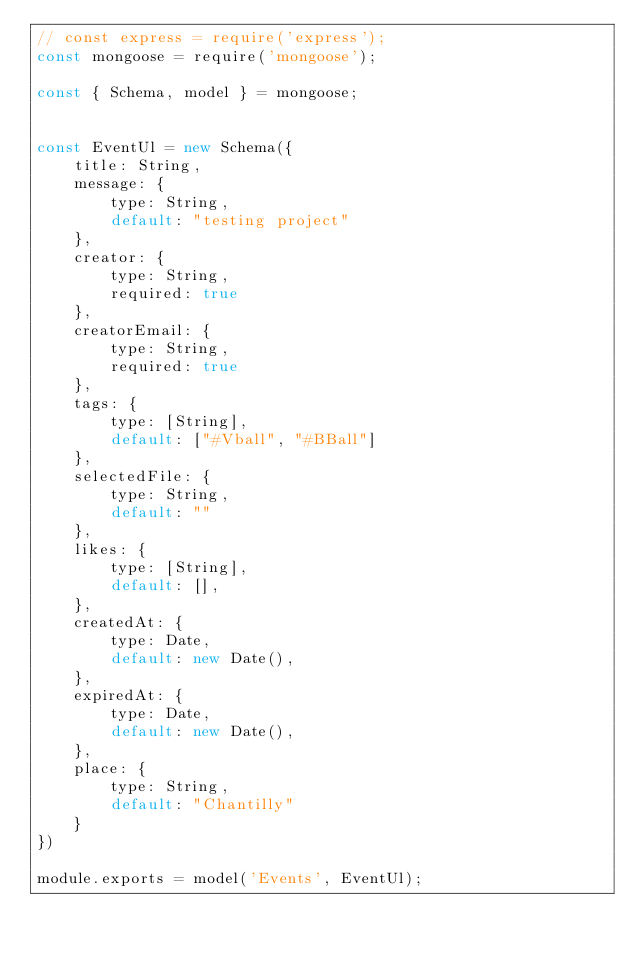Convert code to text. <code><loc_0><loc_0><loc_500><loc_500><_JavaScript_>// const express = require('express');
const mongoose = require('mongoose');

const { Schema, model } = mongoose;


const EventUl = new Schema({
    title: String,
    message: {
        type: String,
        default: "testing project"
    },
    creator: {
        type: String,
        required: true
    },
    creatorEmail: {
        type: String,
        required: true
    },
    tags: {
        type: [String],
        default: ["#Vball", "#BBall"]
    },
    selectedFile: {
        type: String,
        default: ""
    },
    likes: {
        type: [String],
        default: [],
    },
    createdAt: {
        type: Date,
        default: new Date(),
    },
    expiredAt: {
        type: Date,
        default: new Date(),
    },
    place: {
        type: String,
        default: "Chantilly"
    }
})

module.exports = model('Events', EventUl);</code> 